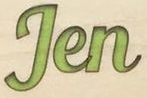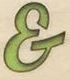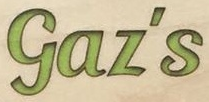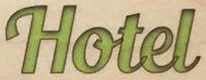What words can you see in these images in sequence, separated by a semicolon? Jen; &; Gaz's; Hotel 